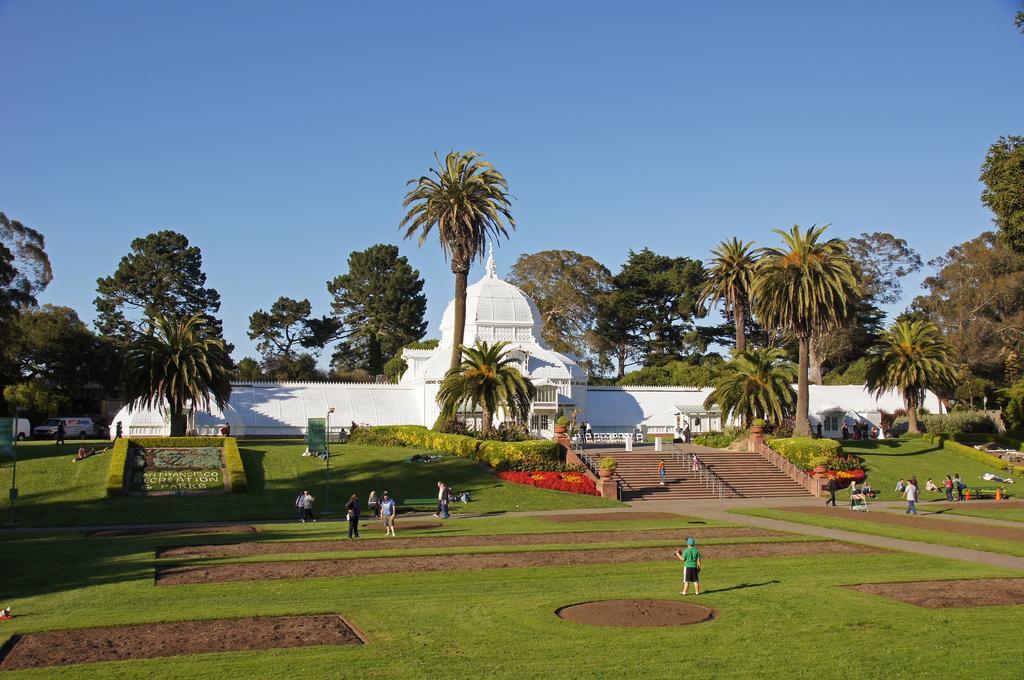In one or two sentences, can you explain what this image depicts? In the Image I can see a house and around there are some trees, plants, people, poles and some grass on the grass. 